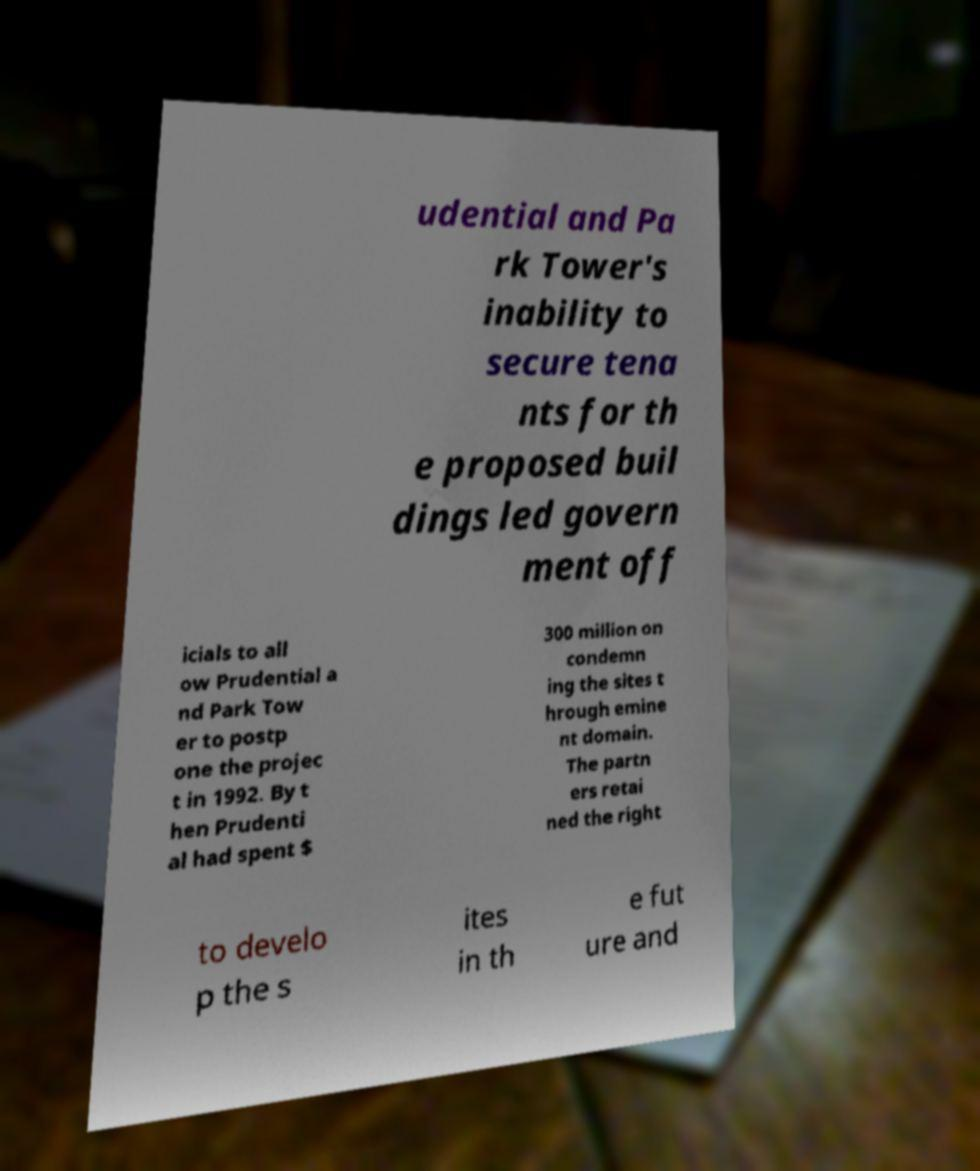Can you accurately transcribe the text from the provided image for me? udential and Pa rk Tower's inability to secure tena nts for th e proposed buil dings led govern ment off icials to all ow Prudential a nd Park Tow er to postp one the projec t in 1992. By t hen Prudenti al had spent $ 300 million on condemn ing the sites t hrough emine nt domain. The partn ers retai ned the right to develo p the s ites in th e fut ure and 